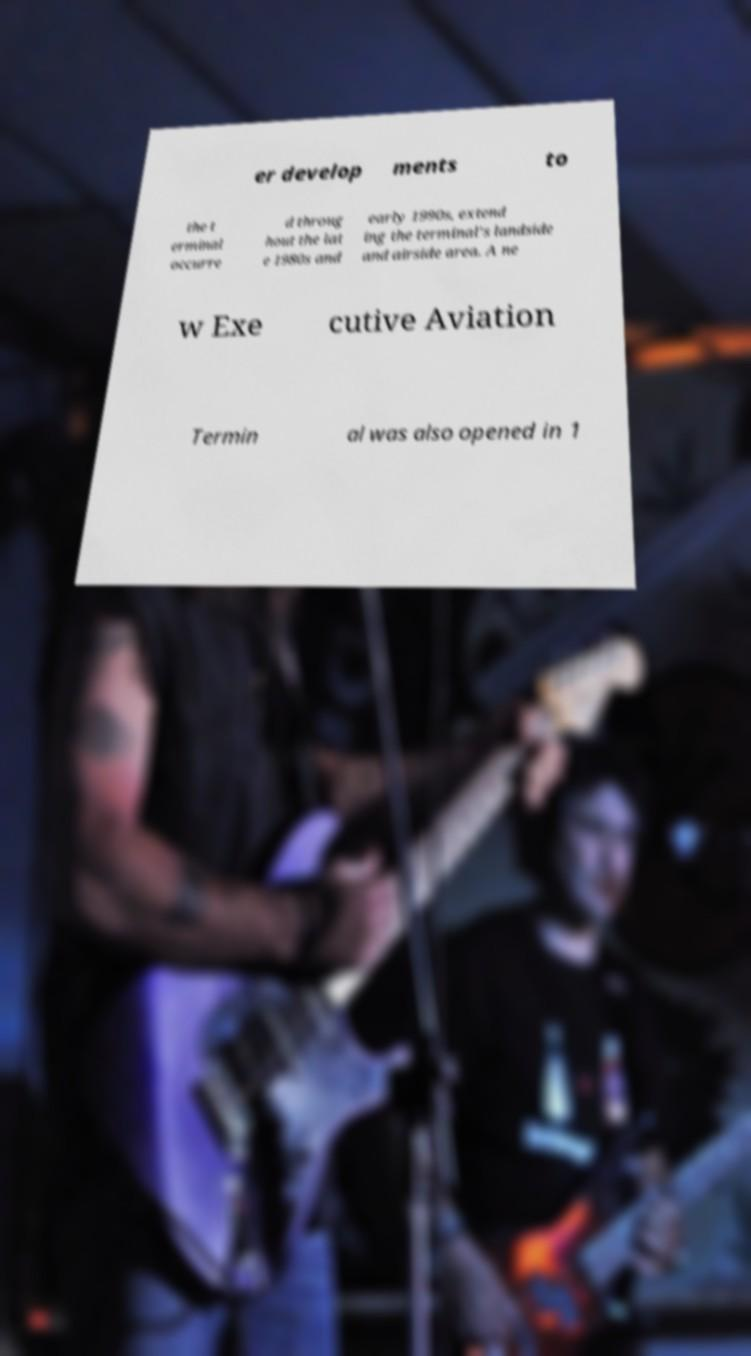I need the written content from this picture converted into text. Can you do that? er develop ments to the t erminal occurre d throug hout the lat e 1980s and early 1990s, extend ing the terminal's landside and airside area. A ne w Exe cutive Aviation Termin al was also opened in 1 